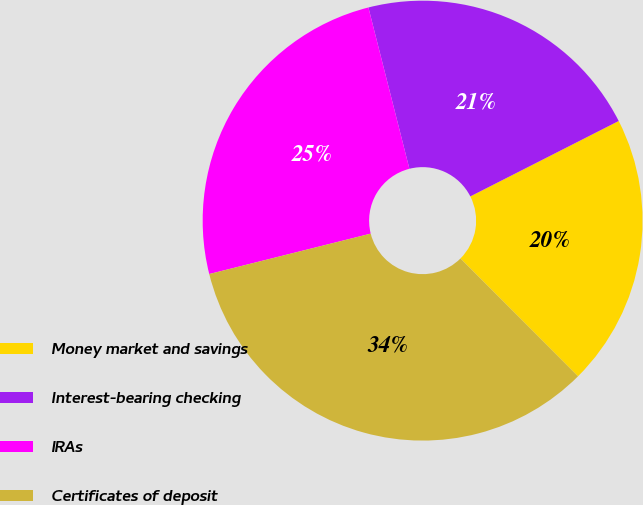Convert chart. <chart><loc_0><loc_0><loc_500><loc_500><pie_chart><fcel>Money market and savings<fcel>Interest-bearing checking<fcel>IRAs<fcel>Certificates of deposit<nl><fcel>20.0%<fcel>21.48%<fcel>24.94%<fcel>33.58%<nl></chart> 